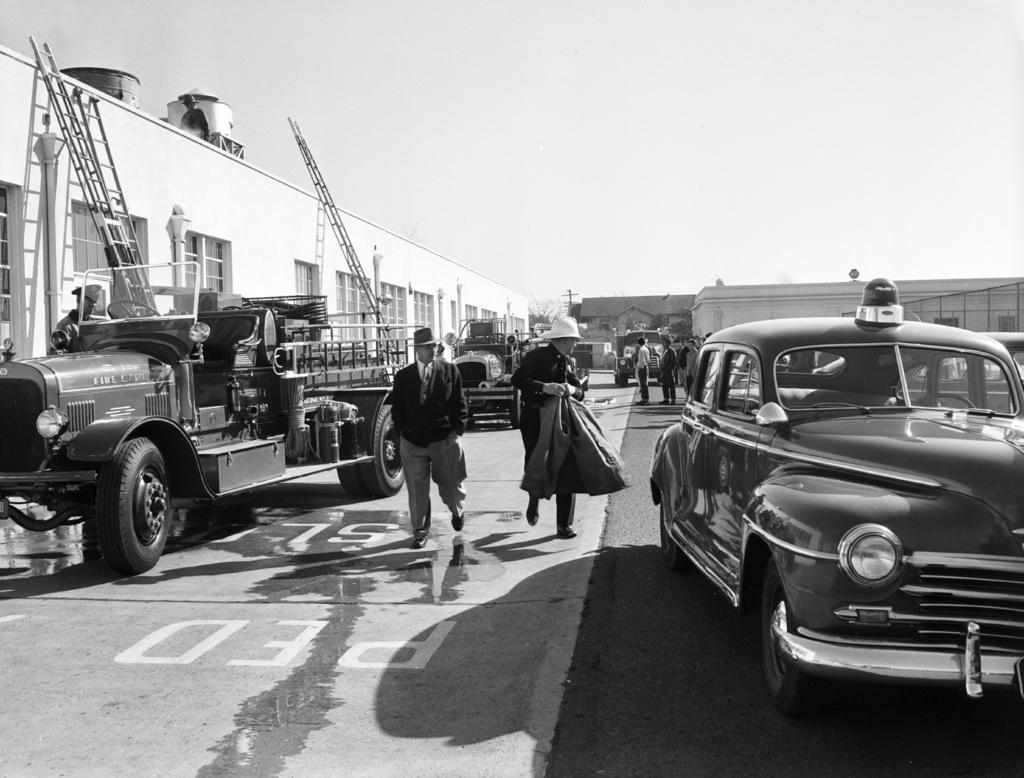In one or two sentences, can you explain what this image depicts? In this picture there are two persons who are walking on the street, beside them I can see the truck and car. In the background I can see many buildings, shed, trucks and other objects. On the left I can see the ladder which are placed on the building. Beside that I can see some windows. At the top I can see the sky. 